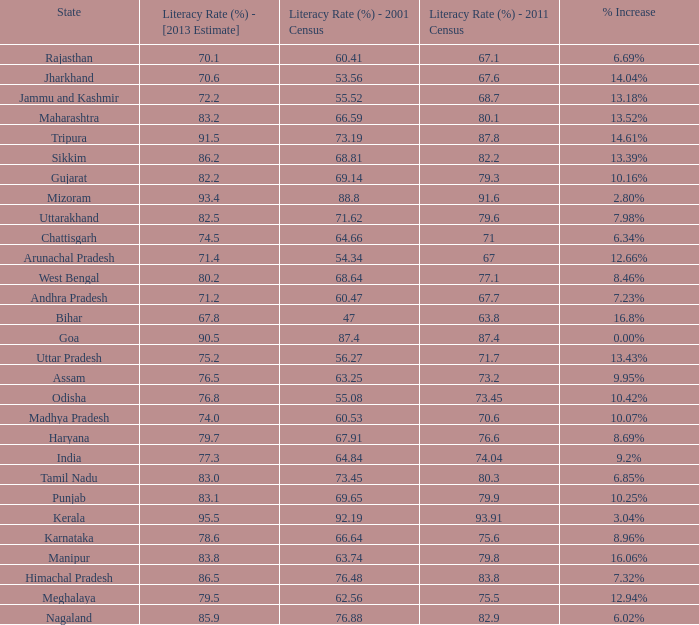What is the average increase in literacy for the states that had a rate higher than 73.2% in 2011, less than 68.81% in 2001, and an estimate of 76.8% for 2013? 10.42%. 